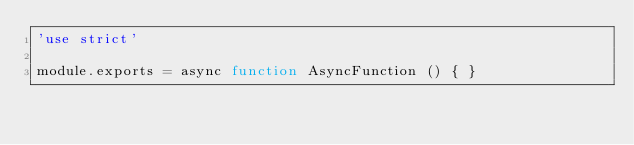<code> <loc_0><loc_0><loc_500><loc_500><_JavaScript_>'use strict'

module.exports = async function AsyncFunction () { }
</code> 